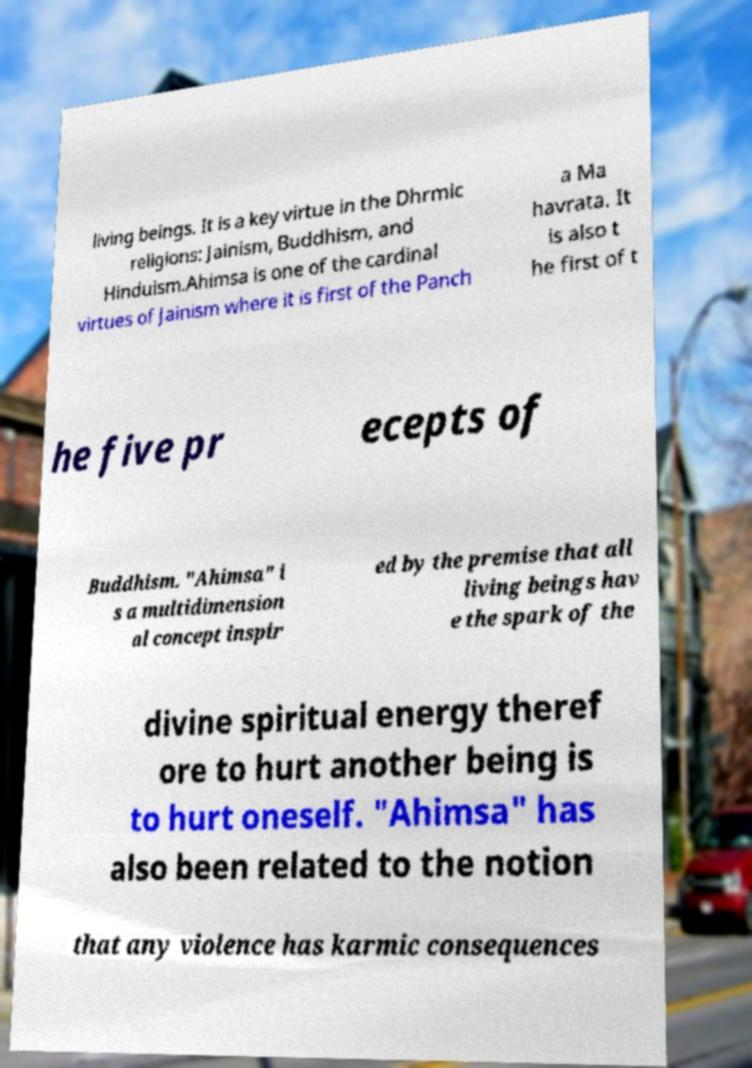Please read and relay the text visible in this image. What does it say? living beings. It is a key virtue in the Dhrmic religions: Jainism, Buddhism, and Hinduism.Ahimsa is one of the cardinal virtues of Jainism where it is first of the Panch a Ma havrata. It is also t he first of t he five pr ecepts of Buddhism. "Ahimsa" i s a multidimension al concept inspir ed by the premise that all living beings hav e the spark of the divine spiritual energy theref ore to hurt another being is to hurt oneself. "Ahimsa" has also been related to the notion that any violence has karmic consequences 